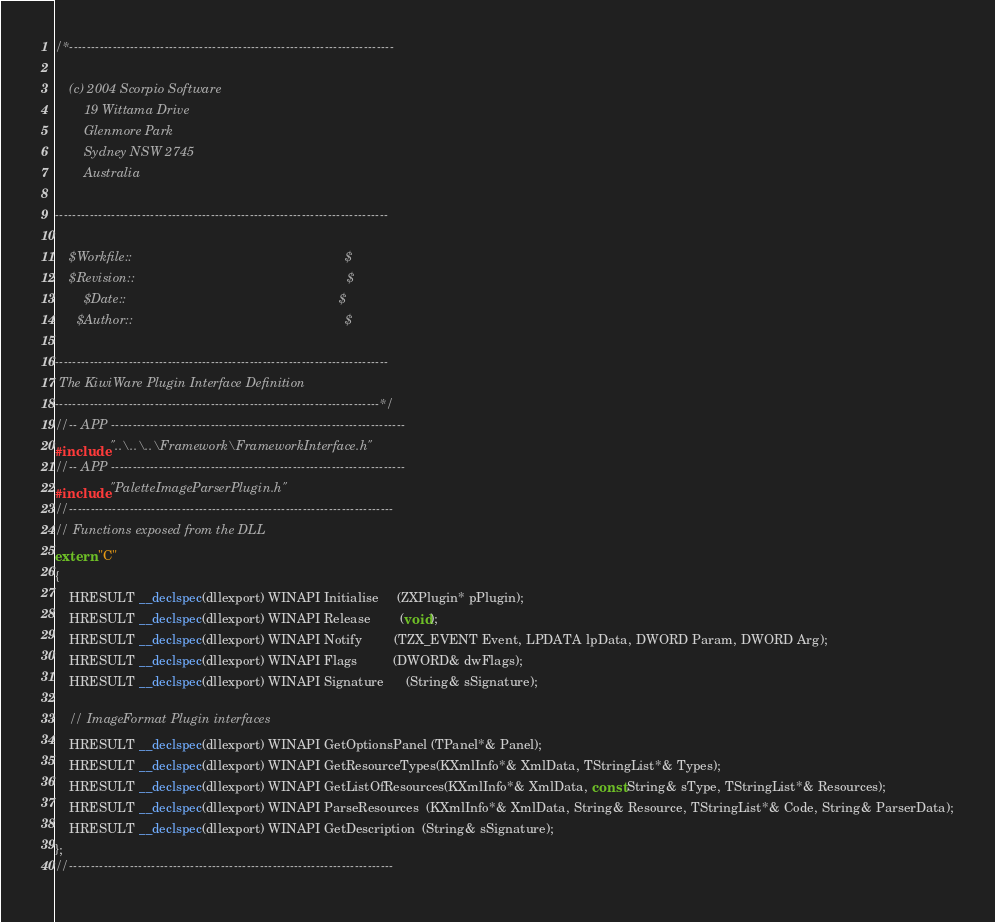Convert code to text. <code><loc_0><loc_0><loc_500><loc_500><_C_>/*---------------------------------------------------------------------------

    (c) 2004 Scorpio Software
        19 Wittama Drive
        Glenmore Park
        Sydney NSW 2745
        Australia

-----------------------------------------------------------------------------

    $Workfile::                                                           $
    $Revision::                                                           $
        $Date::                                                           $
      $Author::                                                           $

-----------------------------------------------------------------------------
 The KiwiWare Plugin Interface Definition
---------------------------------------------------------------------------*/
//-- APP --------------------------------------------------------------------
#include "..\..\..\Framework\FrameworkInterface.h"
//-- APP --------------------------------------------------------------------
#include "PaletteImageParserPlugin.h"
//---------------------------------------------------------------------------
// Functions exposed from the DLL
extern "C"
{
    HRESULT __declspec(dllexport) WINAPI Initialise     (ZXPlugin* pPlugin);
    HRESULT __declspec(dllexport) WINAPI Release        (void);
    HRESULT __declspec(dllexport) WINAPI Notify         (TZX_EVENT Event, LPDATA lpData, DWORD Param, DWORD Arg);
    HRESULT __declspec(dllexport) WINAPI Flags          (DWORD& dwFlags);
    HRESULT __declspec(dllexport) WINAPI Signature      (String& sSignature);

    // ImageFormat Plugin interfaces
    HRESULT __declspec(dllexport) WINAPI GetOptionsPanel (TPanel*& Panel);
    HRESULT __declspec(dllexport) WINAPI GetResourceTypes(KXmlInfo*& XmlData, TStringList*& Types);
    HRESULT __declspec(dllexport) WINAPI GetListOfResources(KXmlInfo*& XmlData, const String& sType, TStringList*& Resources);
    HRESULT __declspec(dllexport) WINAPI ParseResources  (KXmlInfo*& XmlData, String& Resource, TStringList*& Code, String& ParserData);
    HRESULT __declspec(dllexport) WINAPI GetDescription  (String& sSignature);
};
//---------------------------------------------------------------------------

</code> 